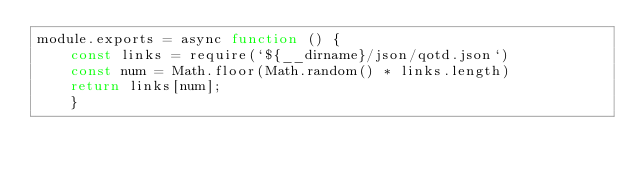<code> <loc_0><loc_0><loc_500><loc_500><_JavaScript_>module.exports = async function () {
	const links = require(`${__dirname}/json/qotd.json`)
	const num = Math.floor(Math.random() * links.length)
	return links[num];
	}</code> 